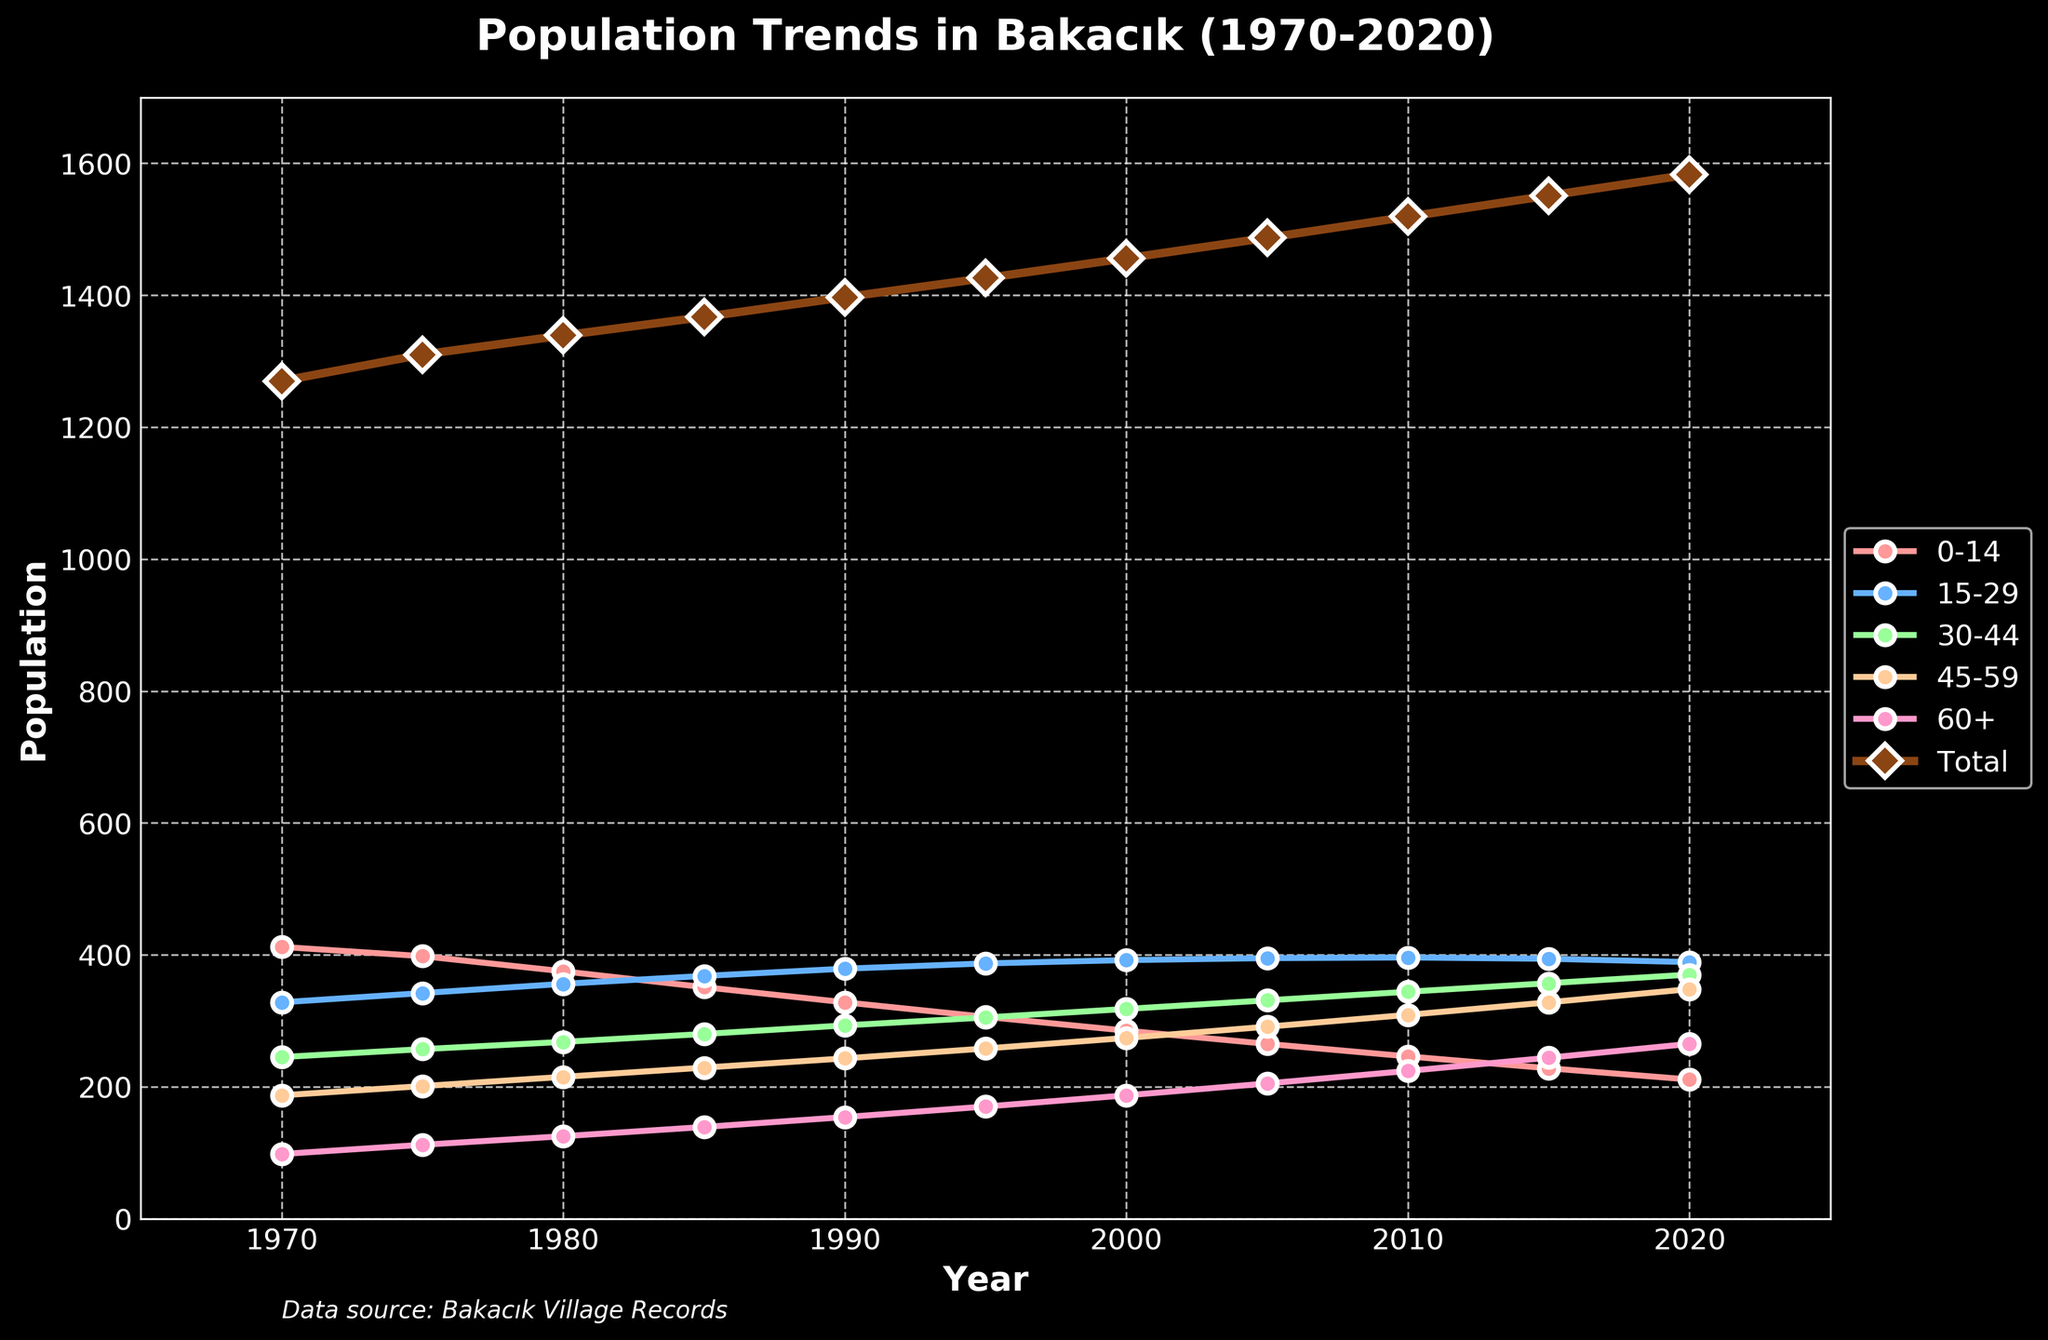What was the total population in 1980? According to the figure, you locate the year 1980 on the x-axis and check the corresponding value of the Total population line.
Answer: 1339 Which age group had the highest population in 2020? Locate the year 2020 on the x-axis and find the population values of each age group, identifying the highest.
Answer: 30-44 What is the average population of the 15-29 age group from 1970 to 2020? Sum the populations of the 15-29 age group over the years (328+342+356+368+379+387+392+395+396+394+389) which equals 4326, and divide by the number of years (11).
Answer: 393 How did the population of the 0-14 age group in 2020 compare to 1970? Compare the population values of the 0-14 age group in 2020 (211) and 1970 (412). Observing that it decreased by 201.
Answer: Decreased by 201 Which age group's population has the most steady increase over time? Observe the slopes and trends of the lines representing each age group. The 60+ age group shows a steady upward trend.
Answer: 60+ By how much did the total population change from 2000 to 2010? Find the total population values for the years 2000 (1456) and 2010 (1519) and compute the difference (1519 - 1456).
Answer: Increased by 63 Which two age groups had the closest population numbers in 1995? Check the population numbers for each age group in 1995. The 15-29 group had 387, and the 30-44 group had 305.
Answer: 15-29 and 30-44 Compare the population trends of the 45-59 and 60+ age groups from 1970 to 2020. Observe that both lines increase, but the 60+ age group's population grows more steadily and significantly than the 45-59 group's population.
Answer: 60+ group increased more steadily What color represents the 0-14 age group on the chart? Identify the color used for the 0-14 age group's line in the chart; it is a light red.
Answer: Light red 